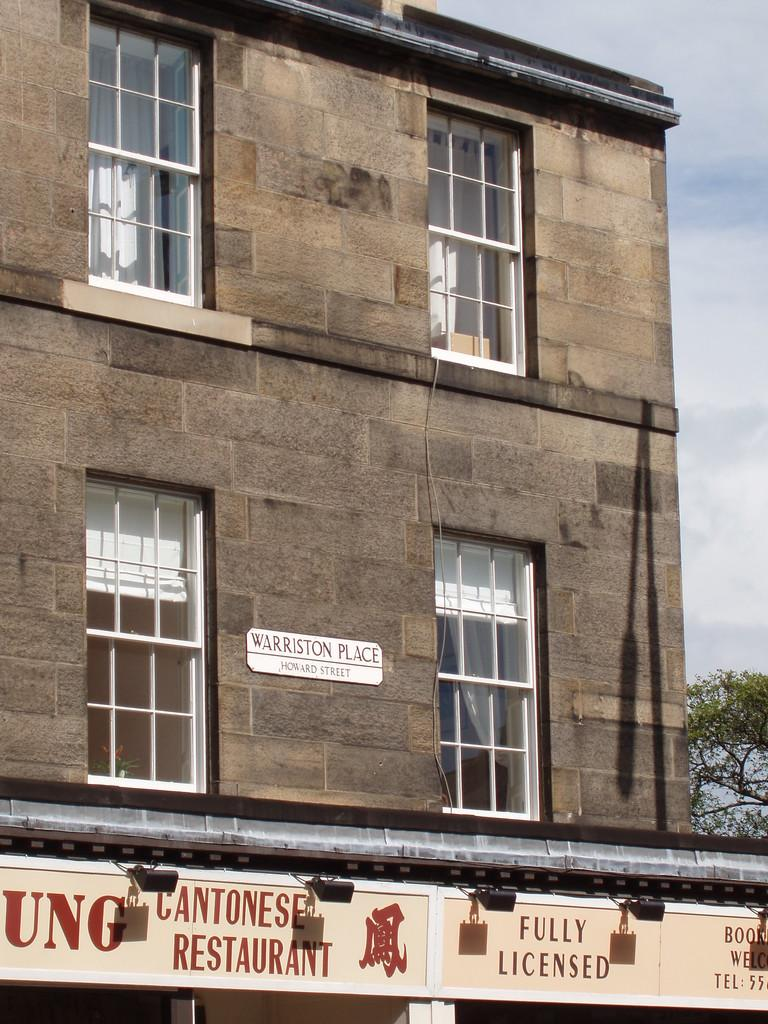What is the color of the building in the image? The building in the image is brown. What type of windows does the building have? The building has glass windows. Is there any signage visible on the building? Yes, there is a shop naming board visible at the front bottom side of the building. What type of iron is used to create the flesh-like texture on the building's exterior? There is no iron or flesh-like texture mentioned in the image. The building has glass windows and a shop naming board, but no details about the materials used in its construction are provided. 